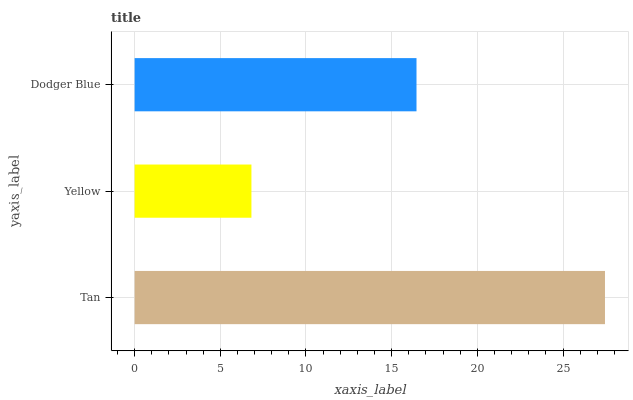Is Yellow the minimum?
Answer yes or no. Yes. Is Tan the maximum?
Answer yes or no. Yes. Is Dodger Blue the minimum?
Answer yes or no. No. Is Dodger Blue the maximum?
Answer yes or no. No. Is Dodger Blue greater than Yellow?
Answer yes or no. Yes. Is Yellow less than Dodger Blue?
Answer yes or no. Yes. Is Yellow greater than Dodger Blue?
Answer yes or no. No. Is Dodger Blue less than Yellow?
Answer yes or no. No. Is Dodger Blue the high median?
Answer yes or no. Yes. Is Dodger Blue the low median?
Answer yes or no. Yes. Is Yellow the high median?
Answer yes or no. No. Is Yellow the low median?
Answer yes or no. No. 